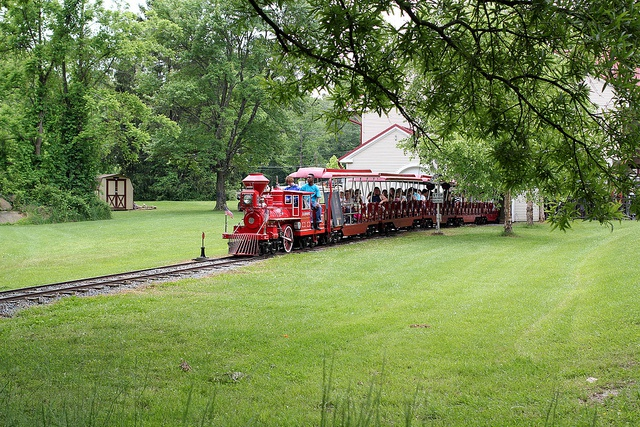Describe the objects in this image and their specific colors. I can see train in olive, black, maroon, gray, and lavender tones, people in olive, black, lightblue, navy, and gray tones, people in olive, black, maroon, gray, and darkgray tones, people in olive, black, gray, and maroon tones, and people in olive, black, gray, maroon, and darkgray tones in this image. 